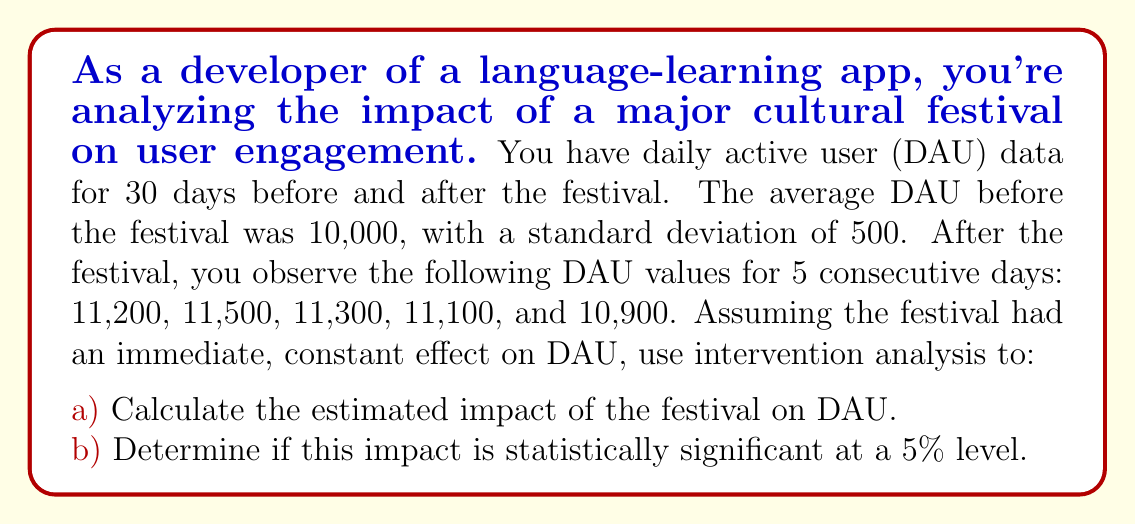Teach me how to tackle this problem. To solve this problem, we'll use intervention analysis, which is a type of time series analysis used to assess the impact of a specific event.

1. Calculate the mean of the post-intervention observations:
   $\bar{y}_{\text{post}} = \frac{11200 + 11500 + 11300 + 11100 + 10900}{5} = 11200$

2. Calculate the estimated impact:
   $\hat{\omega} = \bar{y}_{\text{post}} - \mu_{\text{pre}} = 11200 - 10000 = 1200$

3. To determine statistical significance, we need to calculate the standard error of the impact estimate:
   $SE(\hat{\omega}) = \sqrt{\frac{\sigma^2_{\text{pre}}}{n_{\text{post}}}} = \sqrt{\frac{500^2}{5}} = 223.61$

4. Calculate the t-statistic:
   $t = \frac{\hat{\omega}}{SE(\hat{\omega})} = \frac{1200}{223.61} = 5.37$

5. Degrees of freedom: $df = n_{\text{post}} - 1 = 5 - 1 = 4$

6. The critical t-value for a two-tailed test at 5% significance level with 4 degrees of freedom is approximately 2.776.

Since our calculated t-statistic (5.37) is greater than the critical value (2.776), we reject the null hypothesis that the impact is zero.
Answer: a) The estimated impact of the festival on DAU is an increase of 1,200 users.
b) The impact is statistically significant at the 5% level (t = 5.37, df = 4, p < 0.05). 